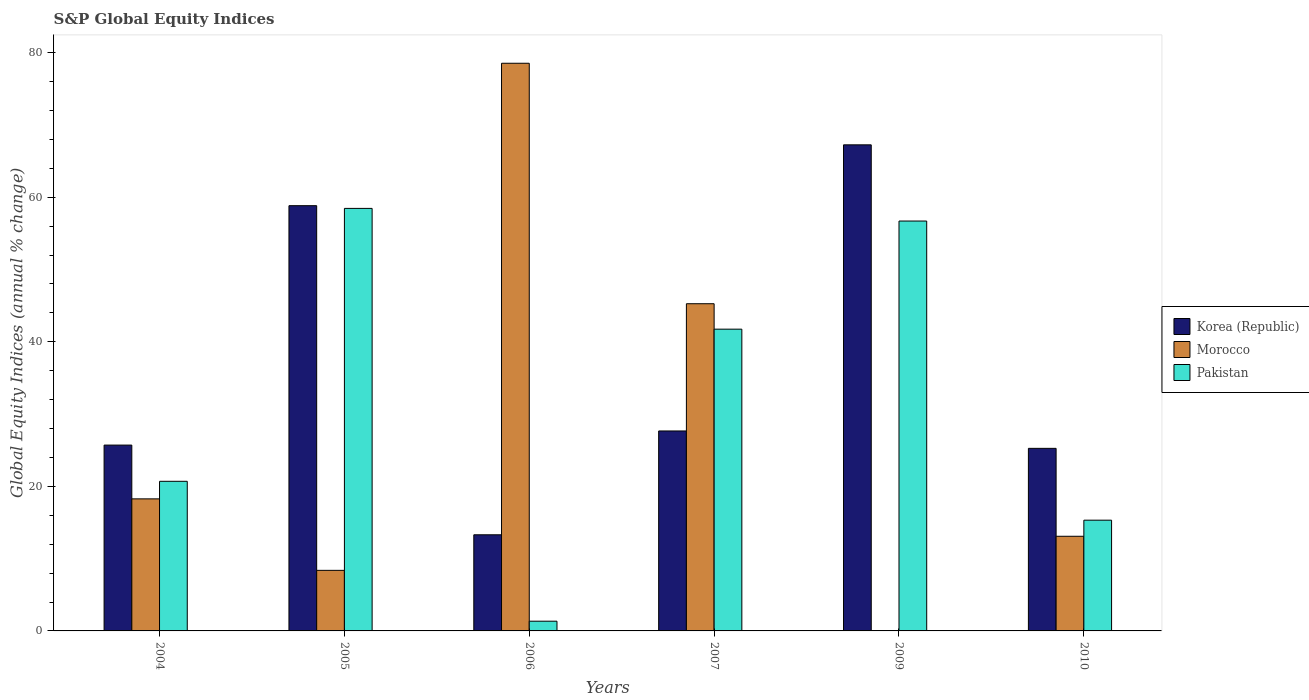How many different coloured bars are there?
Offer a very short reply. 3. In how many cases, is the number of bars for a given year not equal to the number of legend labels?
Give a very brief answer. 1. What is the global equity indices in Korea (Republic) in 2009?
Keep it short and to the point. 67.25. Across all years, what is the maximum global equity indices in Morocco?
Give a very brief answer. 78.53. Across all years, what is the minimum global equity indices in Korea (Republic)?
Keep it short and to the point. 13.3. What is the total global equity indices in Korea (Republic) in the graph?
Your response must be concise. 218.01. What is the difference between the global equity indices in Pakistan in 2007 and that in 2009?
Your answer should be very brief. -14.96. What is the difference between the global equity indices in Morocco in 2009 and the global equity indices in Korea (Republic) in 2004?
Offer a very short reply. -25.71. What is the average global equity indices in Pakistan per year?
Provide a short and direct response. 32.38. In the year 2006, what is the difference between the global equity indices in Korea (Republic) and global equity indices in Pakistan?
Your answer should be very brief. 11.95. In how many years, is the global equity indices in Korea (Republic) greater than 60 %?
Your response must be concise. 1. What is the ratio of the global equity indices in Korea (Republic) in 2006 to that in 2010?
Provide a short and direct response. 0.53. Is the global equity indices in Pakistan in 2007 less than that in 2010?
Provide a succinct answer. No. Is the difference between the global equity indices in Korea (Republic) in 2004 and 2010 greater than the difference between the global equity indices in Pakistan in 2004 and 2010?
Provide a succinct answer. No. What is the difference between the highest and the second highest global equity indices in Pakistan?
Give a very brief answer. 1.75. What is the difference between the highest and the lowest global equity indices in Korea (Republic)?
Make the answer very short. 53.95. Is it the case that in every year, the sum of the global equity indices in Pakistan and global equity indices in Korea (Republic) is greater than the global equity indices in Morocco?
Offer a very short reply. No. How many years are there in the graph?
Your answer should be compact. 6. What is the difference between two consecutive major ticks on the Y-axis?
Provide a succinct answer. 20. Are the values on the major ticks of Y-axis written in scientific E-notation?
Your answer should be compact. No. Does the graph contain any zero values?
Make the answer very short. Yes. How many legend labels are there?
Your response must be concise. 3. How are the legend labels stacked?
Offer a terse response. Vertical. What is the title of the graph?
Your response must be concise. S&P Global Equity Indices. Does "Niger" appear as one of the legend labels in the graph?
Make the answer very short. No. What is the label or title of the Y-axis?
Ensure brevity in your answer.  Global Equity Indices (annual % change). What is the Global Equity Indices (annual % change) in Korea (Republic) in 2004?
Your answer should be compact. 25.71. What is the Global Equity Indices (annual % change) in Morocco in 2004?
Offer a terse response. 18.27. What is the Global Equity Indices (annual % change) in Pakistan in 2004?
Offer a very short reply. 20.7. What is the Global Equity Indices (annual % change) of Korea (Republic) in 2005?
Your response must be concise. 58.83. What is the Global Equity Indices (annual % change) of Morocco in 2005?
Offer a terse response. 8.38. What is the Global Equity Indices (annual % change) of Pakistan in 2005?
Offer a terse response. 58.45. What is the Global Equity Indices (annual % change) of Korea (Republic) in 2006?
Offer a very short reply. 13.3. What is the Global Equity Indices (annual % change) in Morocco in 2006?
Keep it short and to the point. 78.53. What is the Global Equity Indices (annual % change) in Pakistan in 2006?
Offer a terse response. 1.35. What is the Global Equity Indices (annual % change) of Korea (Republic) in 2007?
Provide a succinct answer. 27.66. What is the Global Equity Indices (annual % change) of Morocco in 2007?
Make the answer very short. 45.27. What is the Global Equity Indices (annual % change) of Pakistan in 2007?
Your answer should be compact. 41.75. What is the Global Equity Indices (annual % change) of Korea (Republic) in 2009?
Offer a very short reply. 67.25. What is the Global Equity Indices (annual % change) in Pakistan in 2009?
Ensure brevity in your answer.  56.71. What is the Global Equity Indices (annual % change) of Korea (Republic) in 2010?
Give a very brief answer. 25.26. What is the Global Equity Indices (annual % change) in Morocco in 2010?
Your response must be concise. 13.1. What is the Global Equity Indices (annual % change) of Pakistan in 2010?
Your answer should be very brief. 15.32. Across all years, what is the maximum Global Equity Indices (annual % change) of Korea (Republic)?
Your answer should be compact. 67.25. Across all years, what is the maximum Global Equity Indices (annual % change) in Morocco?
Your response must be concise. 78.53. Across all years, what is the maximum Global Equity Indices (annual % change) of Pakistan?
Your answer should be very brief. 58.45. Across all years, what is the minimum Global Equity Indices (annual % change) of Korea (Republic)?
Provide a short and direct response. 13.3. Across all years, what is the minimum Global Equity Indices (annual % change) in Morocco?
Ensure brevity in your answer.  0. Across all years, what is the minimum Global Equity Indices (annual % change) in Pakistan?
Offer a very short reply. 1.35. What is the total Global Equity Indices (annual % change) in Korea (Republic) in the graph?
Provide a succinct answer. 218.01. What is the total Global Equity Indices (annual % change) in Morocco in the graph?
Your response must be concise. 163.55. What is the total Global Equity Indices (annual % change) of Pakistan in the graph?
Your answer should be compact. 194.27. What is the difference between the Global Equity Indices (annual % change) in Korea (Republic) in 2004 and that in 2005?
Offer a very short reply. -33.12. What is the difference between the Global Equity Indices (annual % change) of Morocco in 2004 and that in 2005?
Your answer should be very brief. 9.89. What is the difference between the Global Equity Indices (annual % change) in Pakistan in 2004 and that in 2005?
Provide a short and direct response. -37.75. What is the difference between the Global Equity Indices (annual % change) in Korea (Republic) in 2004 and that in 2006?
Offer a terse response. 12.41. What is the difference between the Global Equity Indices (annual % change) of Morocco in 2004 and that in 2006?
Your answer should be compact. -60.26. What is the difference between the Global Equity Indices (annual % change) of Pakistan in 2004 and that in 2006?
Make the answer very short. 19.35. What is the difference between the Global Equity Indices (annual % change) in Korea (Republic) in 2004 and that in 2007?
Offer a terse response. -1.95. What is the difference between the Global Equity Indices (annual % change) in Morocco in 2004 and that in 2007?
Offer a very short reply. -27. What is the difference between the Global Equity Indices (annual % change) in Pakistan in 2004 and that in 2007?
Offer a terse response. -21.05. What is the difference between the Global Equity Indices (annual % change) of Korea (Republic) in 2004 and that in 2009?
Give a very brief answer. -41.54. What is the difference between the Global Equity Indices (annual % change) of Pakistan in 2004 and that in 2009?
Provide a short and direct response. -36.01. What is the difference between the Global Equity Indices (annual % change) in Korea (Republic) in 2004 and that in 2010?
Give a very brief answer. 0.45. What is the difference between the Global Equity Indices (annual % change) of Morocco in 2004 and that in 2010?
Provide a succinct answer. 5.17. What is the difference between the Global Equity Indices (annual % change) in Pakistan in 2004 and that in 2010?
Make the answer very short. 5.38. What is the difference between the Global Equity Indices (annual % change) in Korea (Republic) in 2005 and that in 2006?
Provide a short and direct response. 45.53. What is the difference between the Global Equity Indices (annual % change) in Morocco in 2005 and that in 2006?
Make the answer very short. -70.16. What is the difference between the Global Equity Indices (annual % change) of Pakistan in 2005 and that in 2006?
Provide a short and direct response. 57.11. What is the difference between the Global Equity Indices (annual % change) of Korea (Republic) in 2005 and that in 2007?
Your answer should be very brief. 31.17. What is the difference between the Global Equity Indices (annual % change) in Morocco in 2005 and that in 2007?
Ensure brevity in your answer.  -36.89. What is the difference between the Global Equity Indices (annual % change) in Pakistan in 2005 and that in 2007?
Offer a terse response. 16.71. What is the difference between the Global Equity Indices (annual % change) in Korea (Republic) in 2005 and that in 2009?
Give a very brief answer. -8.42. What is the difference between the Global Equity Indices (annual % change) of Pakistan in 2005 and that in 2009?
Your answer should be very brief. 1.75. What is the difference between the Global Equity Indices (annual % change) of Korea (Republic) in 2005 and that in 2010?
Keep it short and to the point. 33.57. What is the difference between the Global Equity Indices (annual % change) in Morocco in 2005 and that in 2010?
Give a very brief answer. -4.72. What is the difference between the Global Equity Indices (annual % change) in Pakistan in 2005 and that in 2010?
Your answer should be compact. 43.13. What is the difference between the Global Equity Indices (annual % change) in Korea (Republic) in 2006 and that in 2007?
Offer a very short reply. -14.36. What is the difference between the Global Equity Indices (annual % change) of Morocco in 2006 and that in 2007?
Provide a succinct answer. 33.27. What is the difference between the Global Equity Indices (annual % change) in Pakistan in 2006 and that in 2007?
Your answer should be compact. -40.4. What is the difference between the Global Equity Indices (annual % change) of Korea (Republic) in 2006 and that in 2009?
Offer a terse response. -53.95. What is the difference between the Global Equity Indices (annual % change) of Pakistan in 2006 and that in 2009?
Provide a succinct answer. -55.36. What is the difference between the Global Equity Indices (annual % change) in Korea (Republic) in 2006 and that in 2010?
Keep it short and to the point. -11.96. What is the difference between the Global Equity Indices (annual % change) of Morocco in 2006 and that in 2010?
Your answer should be very brief. 65.44. What is the difference between the Global Equity Indices (annual % change) in Pakistan in 2006 and that in 2010?
Offer a terse response. -13.97. What is the difference between the Global Equity Indices (annual % change) in Korea (Republic) in 2007 and that in 2009?
Offer a terse response. -39.59. What is the difference between the Global Equity Indices (annual % change) of Pakistan in 2007 and that in 2009?
Your response must be concise. -14.96. What is the difference between the Global Equity Indices (annual % change) of Korea (Republic) in 2007 and that in 2010?
Keep it short and to the point. 2.41. What is the difference between the Global Equity Indices (annual % change) of Morocco in 2007 and that in 2010?
Keep it short and to the point. 32.17. What is the difference between the Global Equity Indices (annual % change) of Pakistan in 2007 and that in 2010?
Give a very brief answer. 26.43. What is the difference between the Global Equity Indices (annual % change) of Korea (Republic) in 2009 and that in 2010?
Provide a short and direct response. 41.99. What is the difference between the Global Equity Indices (annual % change) in Pakistan in 2009 and that in 2010?
Ensure brevity in your answer.  41.39. What is the difference between the Global Equity Indices (annual % change) of Korea (Republic) in 2004 and the Global Equity Indices (annual % change) of Morocco in 2005?
Your answer should be very brief. 17.33. What is the difference between the Global Equity Indices (annual % change) in Korea (Republic) in 2004 and the Global Equity Indices (annual % change) in Pakistan in 2005?
Offer a terse response. -32.74. What is the difference between the Global Equity Indices (annual % change) in Morocco in 2004 and the Global Equity Indices (annual % change) in Pakistan in 2005?
Your answer should be very brief. -40.18. What is the difference between the Global Equity Indices (annual % change) of Korea (Republic) in 2004 and the Global Equity Indices (annual % change) of Morocco in 2006?
Provide a succinct answer. -52.82. What is the difference between the Global Equity Indices (annual % change) of Korea (Republic) in 2004 and the Global Equity Indices (annual % change) of Pakistan in 2006?
Your answer should be compact. 24.36. What is the difference between the Global Equity Indices (annual % change) of Morocco in 2004 and the Global Equity Indices (annual % change) of Pakistan in 2006?
Keep it short and to the point. 16.92. What is the difference between the Global Equity Indices (annual % change) in Korea (Republic) in 2004 and the Global Equity Indices (annual % change) in Morocco in 2007?
Offer a very short reply. -19.56. What is the difference between the Global Equity Indices (annual % change) in Korea (Republic) in 2004 and the Global Equity Indices (annual % change) in Pakistan in 2007?
Your response must be concise. -16.04. What is the difference between the Global Equity Indices (annual % change) of Morocco in 2004 and the Global Equity Indices (annual % change) of Pakistan in 2007?
Your answer should be compact. -23.48. What is the difference between the Global Equity Indices (annual % change) in Korea (Republic) in 2004 and the Global Equity Indices (annual % change) in Pakistan in 2009?
Give a very brief answer. -31. What is the difference between the Global Equity Indices (annual % change) in Morocco in 2004 and the Global Equity Indices (annual % change) in Pakistan in 2009?
Your answer should be very brief. -38.44. What is the difference between the Global Equity Indices (annual % change) of Korea (Republic) in 2004 and the Global Equity Indices (annual % change) of Morocco in 2010?
Your answer should be compact. 12.62. What is the difference between the Global Equity Indices (annual % change) of Korea (Republic) in 2004 and the Global Equity Indices (annual % change) of Pakistan in 2010?
Ensure brevity in your answer.  10.39. What is the difference between the Global Equity Indices (annual % change) in Morocco in 2004 and the Global Equity Indices (annual % change) in Pakistan in 2010?
Offer a terse response. 2.95. What is the difference between the Global Equity Indices (annual % change) in Korea (Republic) in 2005 and the Global Equity Indices (annual % change) in Morocco in 2006?
Offer a terse response. -19.7. What is the difference between the Global Equity Indices (annual % change) in Korea (Republic) in 2005 and the Global Equity Indices (annual % change) in Pakistan in 2006?
Your answer should be compact. 57.48. What is the difference between the Global Equity Indices (annual % change) in Morocco in 2005 and the Global Equity Indices (annual % change) in Pakistan in 2006?
Your answer should be very brief. 7.03. What is the difference between the Global Equity Indices (annual % change) of Korea (Republic) in 2005 and the Global Equity Indices (annual % change) of Morocco in 2007?
Your answer should be compact. 13.56. What is the difference between the Global Equity Indices (annual % change) in Korea (Republic) in 2005 and the Global Equity Indices (annual % change) in Pakistan in 2007?
Offer a terse response. 17.08. What is the difference between the Global Equity Indices (annual % change) of Morocco in 2005 and the Global Equity Indices (annual % change) of Pakistan in 2007?
Provide a succinct answer. -33.37. What is the difference between the Global Equity Indices (annual % change) of Korea (Republic) in 2005 and the Global Equity Indices (annual % change) of Pakistan in 2009?
Your answer should be very brief. 2.12. What is the difference between the Global Equity Indices (annual % change) of Morocco in 2005 and the Global Equity Indices (annual % change) of Pakistan in 2009?
Offer a terse response. -48.33. What is the difference between the Global Equity Indices (annual % change) in Korea (Republic) in 2005 and the Global Equity Indices (annual % change) in Morocco in 2010?
Your answer should be compact. 45.74. What is the difference between the Global Equity Indices (annual % change) of Korea (Republic) in 2005 and the Global Equity Indices (annual % change) of Pakistan in 2010?
Your answer should be very brief. 43.51. What is the difference between the Global Equity Indices (annual % change) in Morocco in 2005 and the Global Equity Indices (annual % change) in Pakistan in 2010?
Your response must be concise. -6.94. What is the difference between the Global Equity Indices (annual % change) in Korea (Republic) in 2006 and the Global Equity Indices (annual % change) in Morocco in 2007?
Your answer should be very brief. -31.97. What is the difference between the Global Equity Indices (annual % change) of Korea (Republic) in 2006 and the Global Equity Indices (annual % change) of Pakistan in 2007?
Ensure brevity in your answer.  -28.45. What is the difference between the Global Equity Indices (annual % change) in Morocco in 2006 and the Global Equity Indices (annual % change) in Pakistan in 2007?
Your response must be concise. 36.79. What is the difference between the Global Equity Indices (annual % change) in Korea (Republic) in 2006 and the Global Equity Indices (annual % change) in Pakistan in 2009?
Ensure brevity in your answer.  -43.41. What is the difference between the Global Equity Indices (annual % change) of Morocco in 2006 and the Global Equity Indices (annual % change) of Pakistan in 2009?
Your response must be concise. 21.83. What is the difference between the Global Equity Indices (annual % change) in Korea (Republic) in 2006 and the Global Equity Indices (annual % change) in Morocco in 2010?
Keep it short and to the point. 0.21. What is the difference between the Global Equity Indices (annual % change) in Korea (Republic) in 2006 and the Global Equity Indices (annual % change) in Pakistan in 2010?
Provide a short and direct response. -2.02. What is the difference between the Global Equity Indices (annual % change) in Morocco in 2006 and the Global Equity Indices (annual % change) in Pakistan in 2010?
Your answer should be compact. 63.21. What is the difference between the Global Equity Indices (annual % change) in Korea (Republic) in 2007 and the Global Equity Indices (annual % change) in Pakistan in 2009?
Offer a terse response. -29.04. What is the difference between the Global Equity Indices (annual % change) of Morocco in 2007 and the Global Equity Indices (annual % change) of Pakistan in 2009?
Your answer should be compact. -11.44. What is the difference between the Global Equity Indices (annual % change) in Korea (Republic) in 2007 and the Global Equity Indices (annual % change) in Morocco in 2010?
Keep it short and to the point. 14.57. What is the difference between the Global Equity Indices (annual % change) in Korea (Republic) in 2007 and the Global Equity Indices (annual % change) in Pakistan in 2010?
Ensure brevity in your answer.  12.34. What is the difference between the Global Equity Indices (annual % change) of Morocco in 2007 and the Global Equity Indices (annual % change) of Pakistan in 2010?
Offer a terse response. 29.95. What is the difference between the Global Equity Indices (annual % change) of Korea (Republic) in 2009 and the Global Equity Indices (annual % change) of Morocco in 2010?
Make the answer very short. 54.15. What is the difference between the Global Equity Indices (annual % change) of Korea (Republic) in 2009 and the Global Equity Indices (annual % change) of Pakistan in 2010?
Your response must be concise. 51.93. What is the average Global Equity Indices (annual % change) in Korea (Republic) per year?
Provide a succinct answer. 36.34. What is the average Global Equity Indices (annual % change) in Morocco per year?
Your answer should be compact. 27.26. What is the average Global Equity Indices (annual % change) in Pakistan per year?
Provide a succinct answer. 32.38. In the year 2004, what is the difference between the Global Equity Indices (annual % change) of Korea (Republic) and Global Equity Indices (annual % change) of Morocco?
Provide a succinct answer. 7.44. In the year 2004, what is the difference between the Global Equity Indices (annual % change) in Korea (Republic) and Global Equity Indices (annual % change) in Pakistan?
Your answer should be compact. 5.01. In the year 2004, what is the difference between the Global Equity Indices (annual % change) in Morocco and Global Equity Indices (annual % change) in Pakistan?
Your response must be concise. -2.43. In the year 2005, what is the difference between the Global Equity Indices (annual % change) of Korea (Republic) and Global Equity Indices (annual % change) of Morocco?
Provide a succinct answer. 50.45. In the year 2005, what is the difference between the Global Equity Indices (annual % change) of Korea (Republic) and Global Equity Indices (annual % change) of Pakistan?
Ensure brevity in your answer.  0.38. In the year 2005, what is the difference between the Global Equity Indices (annual % change) of Morocco and Global Equity Indices (annual % change) of Pakistan?
Offer a very short reply. -50.07. In the year 2006, what is the difference between the Global Equity Indices (annual % change) of Korea (Republic) and Global Equity Indices (annual % change) of Morocco?
Keep it short and to the point. -65.23. In the year 2006, what is the difference between the Global Equity Indices (annual % change) of Korea (Republic) and Global Equity Indices (annual % change) of Pakistan?
Offer a very short reply. 11.95. In the year 2006, what is the difference between the Global Equity Indices (annual % change) of Morocco and Global Equity Indices (annual % change) of Pakistan?
Your answer should be compact. 77.19. In the year 2007, what is the difference between the Global Equity Indices (annual % change) in Korea (Republic) and Global Equity Indices (annual % change) in Morocco?
Offer a terse response. -17.6. In the year 2007, what is the difference between the Global Equity Indices (annual % change) in Korea (Republic) and Global Equity Indices (annual % change) in Pakistan?
Make the answer very short. -14.08. In the year 2007, what is the difference between the Global Equity Indices (annual % change) of Morocco and Global Equity Indices (annual % change) of Pakistan?
Your answer should be compact. 3.52. In the year 2009, what is the difference between the Global Equity Indices (annual % change) of Korea (Republic) and Global Equity Indices (annual % change) of Pakistan?
Give a very brief answer. 10.54. In the year 2010, what is the difference between the Global Equity Indices (annual % change) of Korea (Republic) and Global Equity Indices (annual % change) of Morocco?
Keep it short and to the point. 12.16. In the year 2010, what is the difference between the Global Equity Indices (annual % change) in Korea (Republic) and Global Equity Indices (annual % change) in Pakistan?
Ensure brevity in your answer.  9.94. In the year 2010, what is the difference between the Global Equity Indices (annual % change) of Morocco and Global Equity Indices (annual % change) of Pakistan?
Offer a very short reply. -2.23. What is the ratio of the Global Equity Indices (annual % change) in Korea (Republic) in 2004 to that in 2005?
Provide a succinct answer. 0.44. What is the ratio of the Global Equity Indices (annual % change) in Morocco in 2004 to that in 2005?
Make the answer very short. 2.18. What is the ratio of the Global Equity Indices (annual % change) of Pakistan in 2004 to that in 2005?
Offer a terse response. 0.35. What is the ratio of the Global Equity Indices (annual % change) in Korea (Republic) in 2004 to that in 2006?
Provide a succinct answer. 1.93. What is the ratio of the Global Equity Indices (annual % change) of Morocco in 2004 to that in 2006?
Provide a short and direct response. 0.23. What is the ratio of the Global Equity Indices (annual % change) in Pakistan in 2004 to that in 2006?
Ensure brevity in your answer.  15.37. What is the ratio of the Global Equity Indices (annual % change) in Korea (Republic) in 2004 to that in 2007?
Offer a very short reply. 0.93. What is the ratio of the Global Equity Indices (annual % change) of Morocco in 2004 to that in 2007?
Ensure brevity in your answer.  0.4. What is the ratio of the Global Equity Indices (annual % change) in Pakistan in 2004 to that in 2007?
Offer a very short reply. 0.5. What is the ratio of the Global Equity Indices (annual % change) of Korea (Republic) in 2004 to that in 2009?
Ensure brevity in your answer.  0.38. What is the ratio of the Global Equity Indices (annual % change) of Pakistan in 2004 to that in 2009?
Offer a very short reply. 0.36. What is the ratio of the Global Equity Indices (annual % change) of Korea (Republic) in 2004 to that in 2010?
Give a very brief answer. 1.02. What is the ratio of the Global Equity Indices (annual % change) in Morocco in 2004 to that in 2010?
Your answer should be very brief. 1.4. What is the ratio of the Global Equity Indices (annual % change) in Pakistan in 2004 to that in 2010?
Make the answer very short. 1.35. What is the ratio of the Global Equity Indices (annual % change) in Korea (Republic) in 2005 to that in 2006?
Your answer should be very brief. 4.42. What is the ratio of the Global Equity Indices (annual % change) of Morocco in 2005 to that in 2006?
Provide a short and direct response. 0.11. What is the ratio of the Global Equity Indices (annual % change) in Pakistan in 2005 to that in 2006?
Provide a succinct answer. 43.41. What is the ratio of the Global Equity Indices (annual % change) of Korea (Republic) in 2005 to that in 2007?
Your answer should be very brief. 2.13. What is the ratio of the Global Equity Indices (annual % change) in Morocco in 2005 to that in 2007?
Ensure brevity in your answer.  0.19. What is the ratio of the Global Equity Indices (annual % change) of Pakistan in 2005 to that in 2007?
Provide a succinct answer. 1.4. What is the ratio of the Global Equity Indices (annual % change) in Korea (Republic) in 2005 to that in 2009?
Provide a short and direct response. 0.87. What is the ratio of the Global Equity Indices (annual % change) in Pakistan in 2005 to that in 2009?
Make the answer very short. 1.03. What is the ratio of the Global Equity Indices (annual % change) in Korea (Republic) in 2005 to that in 2010?
Keep it short and to the point. 2.33. What is the ratio of the Global Equity Indices (annual % change) in Morocco in 2005 to that in 2010?
Provide a succinct answer. 0.64. What is the ratio of the Global Equity Indices (annual % change) in Pakistan in 2005 to that in 2010?
Provide a succinct answer. 3.82. What is the ratio of the Global Equity Indices (annual % change) in Korea (Republic) in 2006 to that in 2007?
Provide a succinct answer. 0.48. What is the ratio of the Global Equity Indices (annual % change) of Morocco in 2006 to that in 2007?
Provide a short and direct response. 1.73. What is the ratio of the Global Equity Indices (annual % change) in Pakistan in 2006 to that in 2007?
Ensure brevity in your answer.  0.03. What is the ratio of the Global Equity Indices (annual % change) of Korea (Republic) in 2006 to that in 2009?
Make the answer very short. 0.2. What is the ratio of the Global Equity Indices (annual % change) in Pakistan in 2006 to that in 2009?
Make the answer very short. 0.02. What is the ratio of the Global Equity Indices (annual % change) in Korea (Republic) in 2006 to that in 2010?
Provide a short and direct response. 0.53. What is the ratio of the Global Equity Indices (annual % change) of Morocco in 2006 to that in 2010?
Offer a very short reply. 6. What is the ratio of the Global Equity Indices (annual % change) of Pakistan in 2006 to that in 2010?
Make the answer very short. 0.09. What is the ratio of the Global Equity Indices (annual % change) in Korea (Republic) in 2007 to that in 2009?
Offer a terse response. 0.41. What is the ratio of the Global Equity Indices (annual % change) in Pakistan in 2007 to that in 2009?
Ensure brevity in your answer.  0.74. What is the ratio of the Global Equity Indices (annual % change) of Korea (Republic) in 2007 to that in 2010?
Your answer should be very brief. 1.1. What is the ratio of the Global Equity Indices (annual % change) of Morocco in 2007 to that in 2010?
Your answer should be compact. 3.46. What is the ratio of the Global Equity Indices (annual % change) in Pakistan in 2007 to that in 2010?
Give a very brief answer. 2.73. What is the ratio of the Global Equity Indices (annual % change) in Korea (Republic) in 2009 to that in 2010?
Ensure brevity in your answer.  2.66. What is the ratio of the Global Equity Indices (annual % change) in Pakistan in 2009 to that in 2010?
Ensure brevity in your answer.  3.7. What is the difference between the highest and the second highest Global Equity Indices (annual % change) in Korea (Republic)?
Ensure brevity in your answer.  8.42. What is the difference between the highest and the second highest Global Equity Indices (annual % change) in Morocco?
Provide a succinct answer. 33.27. What is the difference between the highest and the second highest Global Equity Indices (annual % change) in Pakistan?
Provide a succinct answer. 1.75. What is the difference between the highest and the lowest Global Equity Indices (annual % change) in Korea (Republic)?
Make the answer very short. 53.95. What is the difference between the highest and the lowest Global Equity Indices (annual % change) in Morocco?
Your answer should be compact. 78.53. What is the difference between the highest and the lowest Global Equity Indices (annual % change) of Pakistan?
Make the answer very short. 57.11. 